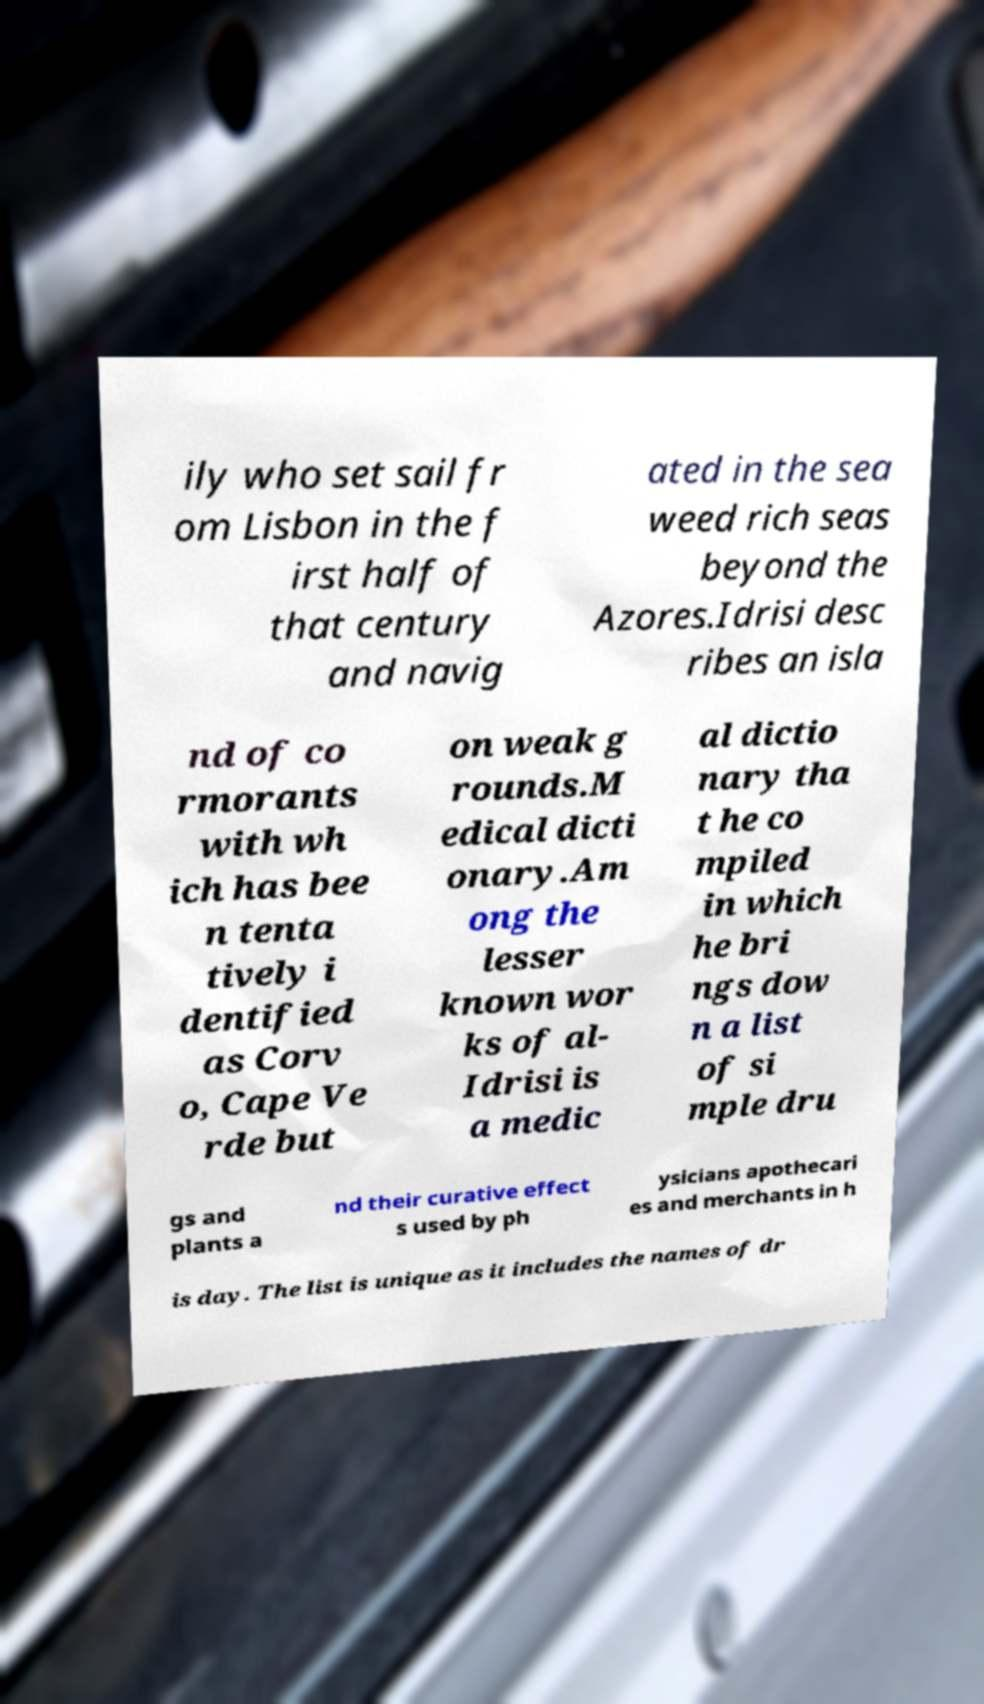There's text embedded in this image that I need extracted. Can you transcribe it verbatim? ily who set sail fr om Lisbon in the f irst half of that century and navig ated in the sea weed rich seas beyond the Azores.Idrisi desc ribes an isla nd of co rmorants with wh ich has bee n tenta tively i dentified as Corv o, Cape Ve rde but on weak g rounds.M edical dicti onary.Am ong the lesser known wor ks of al- Idrisi is a medic al dictio nary tha t he co mpiled in which he bri ngs dow n a list of si mple dru gs and plants a nd their curative effect s used by ph ysicians apothecari es and merchants in h is day. The list is unique as it includes the names of dr 